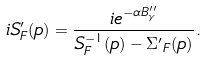<formula> <loc_0><loc_0><loc_500><loc_500>i S ^ { \prime } _ { F } ( p ) = \frac { i e ^ { - \alpha B ^ { \prime \prime } _ { \gamma } } } { S ^ { - 1 } _ { F } ( p ) - { \Sigma ^ { \prime } } _ { F } ( p ) } .</formula> 